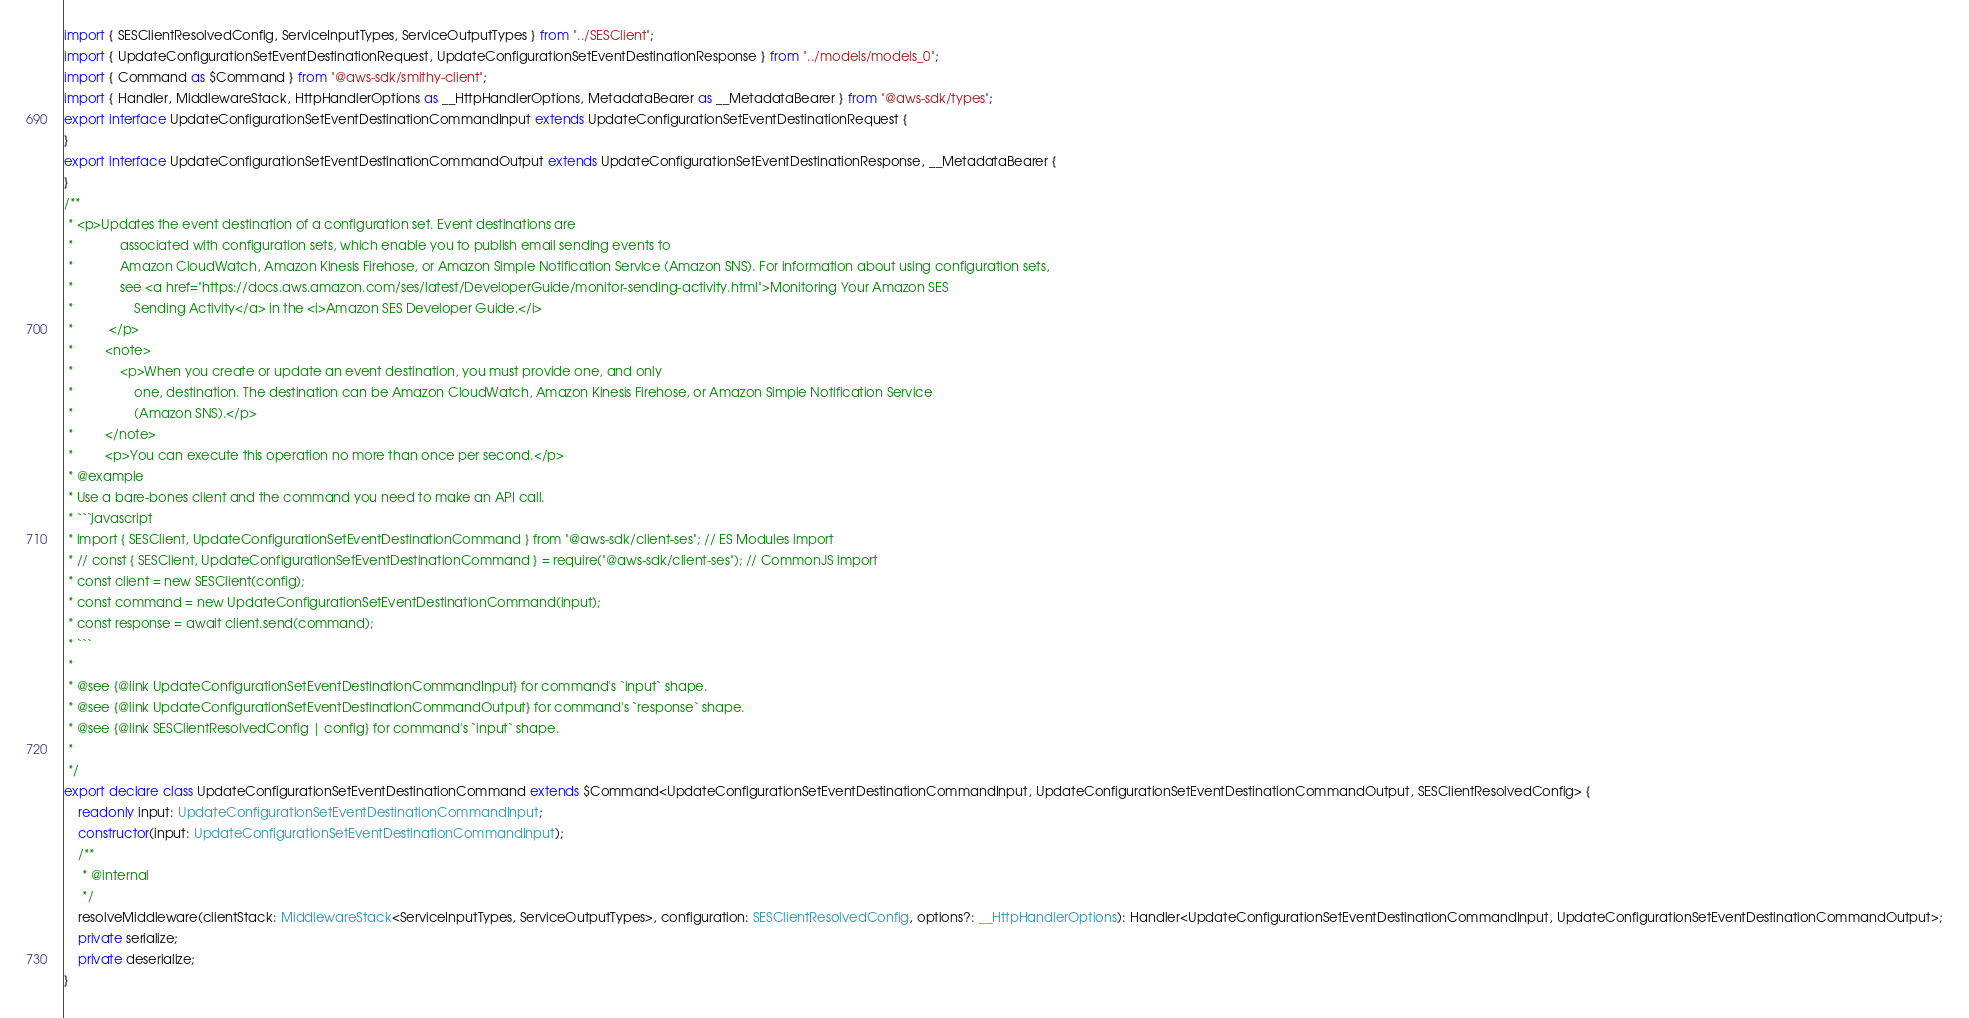<code> <loc_0><loc_0><loc_500><loc_500><_TypeScript_>import { SESClientResolvedConfig, ServiceInputTypes, ServiceOutputTypes } from "../SESClient";
import { UpdateConfigurationSetEventDestinationRequest, UpdateConfigurationSetEventDestinationResponse } from "../models/models_0";
import { Command as $Command } from "@aws-sdk/smithy-client";
import { Handler, MiddlewareStack, HttpHandlerOptions as __HttpHandlerOptions, MetadataBearer as __MetadataBearer } from "@aws-sdk/types";
export interface UpdateConfigurationSetEventDestinationCommandInput extends UpdateConfigurationSetEventDestinationRequest {
}
export interface UpdateConfigurationSetEventDestinationCommandOutput extends UpdateConfigurationSetEventDestinationResponse, __MetadataBearer {
}
/**
 * <p>Updates the event destination of a configuration set. Event destinations are
 *             associated with configuration sets, which enable you to publish email sending events to
 *             Amazon CloudWatch, Amazon Kinesis Firehose, or Amazon Simple Notification Service (Amazon SNS). For information about using configuration sets,
 *             see <a href="https://docs.aws.amazon.com/ses/latest/DeveloperGuide/monitor-sending-activity.html">Monitoring Your Amazon SES
 *                 Sending Activity</a> in the <i>Amazon SES Developer Guide.</i>
 *          </p>
 *         <note>
 *             <p>When you create or update an event destination, you must provide one, and only
 *                 one, destination. The destination can be Amazon CloudWatch, Amazon Kinesis Firehose, or Amazon Simple Notification Service
 *                 (Amazon SNS).</p>
 *         </note>
 *         <p>You can execute this operation no more than once per second.</p>
 * @example
 * Use a bare-bones client and the command you need to make an API call.
 * ```javascript
 * import { SESClient, UpdateConfigurationSetEventDestinationCommand } from "@aws-sdk/client-ses"; // ES Modules import
 * // const { SESClient, UpdateConfigurationSetEventDestinationCommand } = require("@aws-sdk/client-ses"); // CommonJS import
 * const client = new SESClient(config);
 * const command = new UpdateConfigurationSetEventDestinationCommand(input);
 * const response = await client.send(command);
 * ```
 *
 * @see {@link UpdateConfigurationSetEventDestinationCommandInput} for command's `input` shape.
 * @see {@link UpdateConfigurationSetEventDestinationCommandOutput} for command's `response` shape.
 * @see {@link SESClientResolvedConfig | config} for command's `input` shape.
 *
 */
export declare class UpdateConfigurationSetEventDestinationCommand extends $Command<UpdateConfigurationSetEventDestinationCommandInput, UpdateConfigurationSetEventDestinationCommandOutput, SESClientResolvedConfig> {
    readonly input: UpdateConfigurationSetEventDestinationCommandInput;
    constructor(input: UpdateConfigurationSetEventDestinationCommandInput);
    /**
     * @internal
     */
    resolveMiddleware(clientStack: MiddlewareStack<ServiceInputTypes, ServiceOutputTypes>, configuration: SESClientResolvedConfig, options?: __HttpHandlerOptions): Handler<UpdateConfigurationSetEventDestinationCommandInput, UpdateConfigurationSetEventDestinationCommandOutput>;
    private serialize;
    private deserialize;
}
</code> 